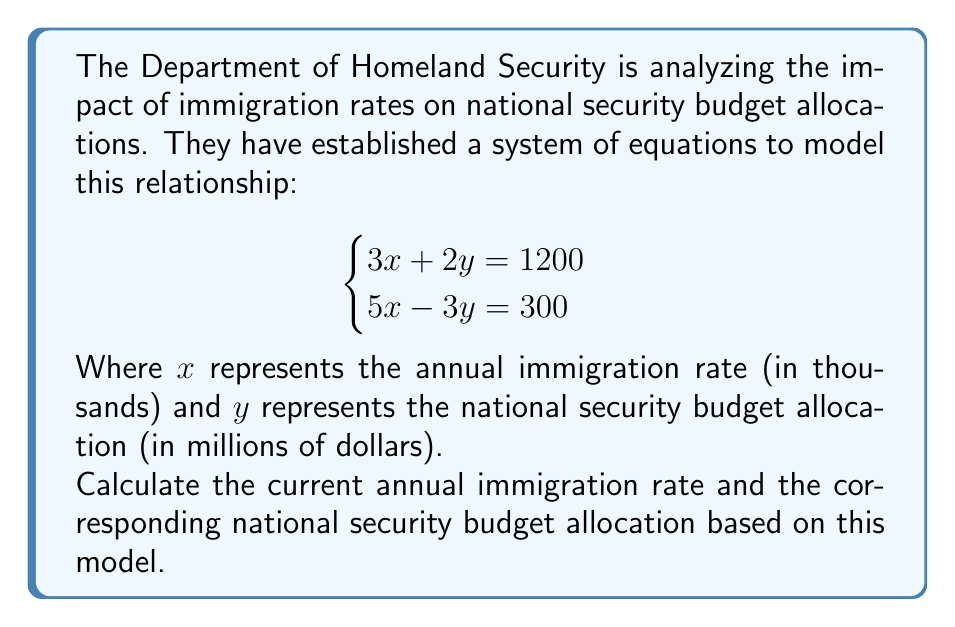Provide a solution to this math problem. To solve this system of equations, we can use the elimination method:

1) Multiply the first equation by 3 and the second equation by 2:

   $$\begin{cases}
   9x + 6y = 3600 \\
   10x - 6y = 600
   \end{cases}$$

2) Add the two equations to eliminate y:

   $19x = 4200$

3) Solve for x:

   $x = \frac{4200}{19} \approx 221.05$

4) Substitute this value of x into one of the original equations to solve for y:

   $3(221.05) + 2y = 1200$
   $663.15 + 2y = 1200$
   $2y = 536.85$
   $y = 268.425$

5) Round the values to make them practical for the context:
   x ≈ 221 thousand (annual immigration rate)
   y ≈ 268 million dollars (national security budget allocation)
Answer: The current annual immigration rate is approximately 221,000, and the corresponding national security budget allocation is approximately $268 million. 